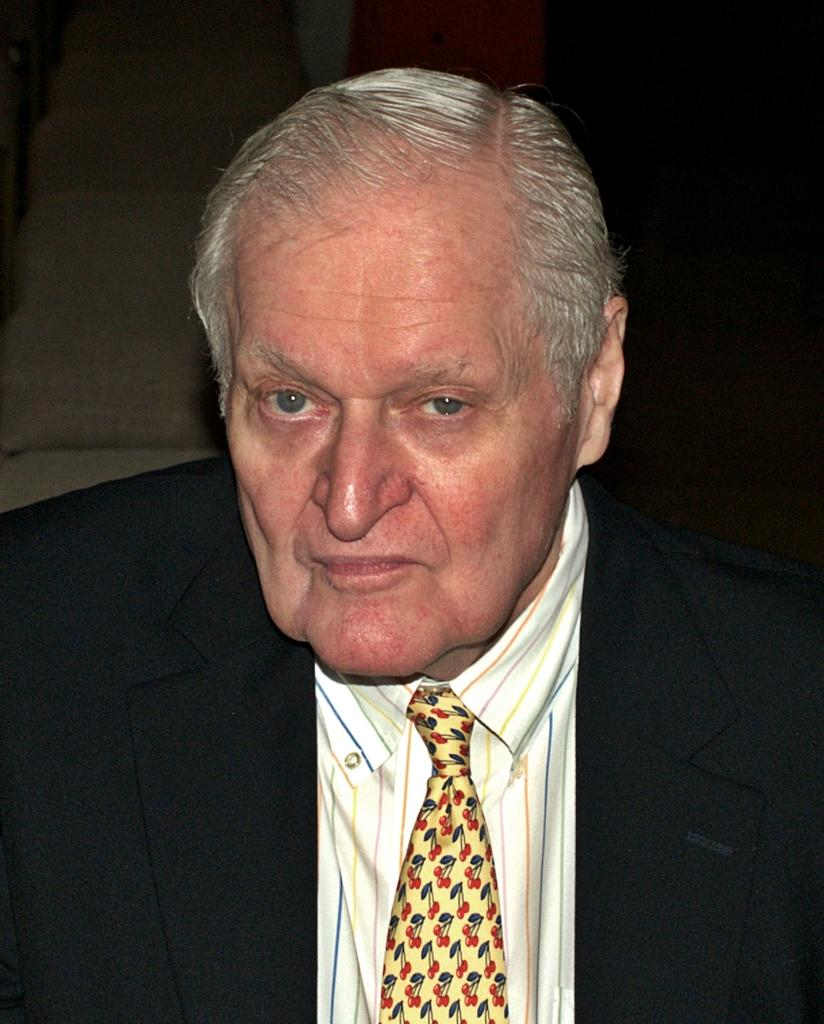Who is the main subject in the image? There is a man in the image. What is the man wearing in the image? The man is wearing a suit and a tie. What can be observed about the background of the image? The background of the image is dark. What type of cord is the man using to fix the wrench in the image? There is no cord or wrench present in the image; the man is wearing a suit and a tie. What news is the man reading in the image? There is no news or reading material present in the image; the man is simply dressed in a suit and a tie. 